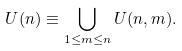Convert formula to latex. <formula><loc_0><loc_0><loc_500><loc_500>U ( n ) \equiv \bigcup _ { 1 \leq m \leq n } U ( n , m ) .</formula> 